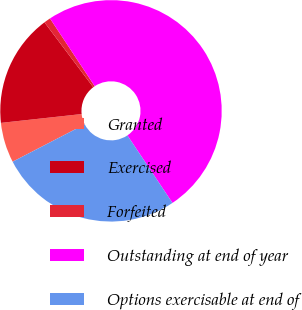<chart> <loc_0><loc_0><loc_500><loc_500><pie_chart><fcel>Granted<fcel>Exercised<fcel>Forfeited<fcel>Outstanding at end of year<fcel>Options exercisable at end of<nl><fcel>5.86%<fcel>16.48%<fcel>0.97%<fcel>49.92%<fcel>26.77%<nl></chart> 